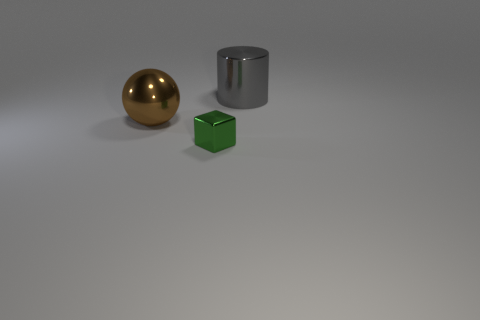Add 2 large cyan shiny objects. How many objects exist? 5 Subtract 1 cubes. How many cubes are left? 0 Add 2 big brown metallic objects. How many big brown metallic objects are left? 3 Add 1 tiny blocks. How many tiny blocks exist? 2 Subtract 1 brown spheres. How many objects are left? 2 Subtract all cubes. How many objects are left? 2 Subtract all red cylinders. Subtract all purple balls. How many cylinders are left? 1 Subtract all yellow spheres. How many brown cylinders are left? 0 Subtract all big blue matte cylinders. Subtract all green objects. How many objects are left? 2 